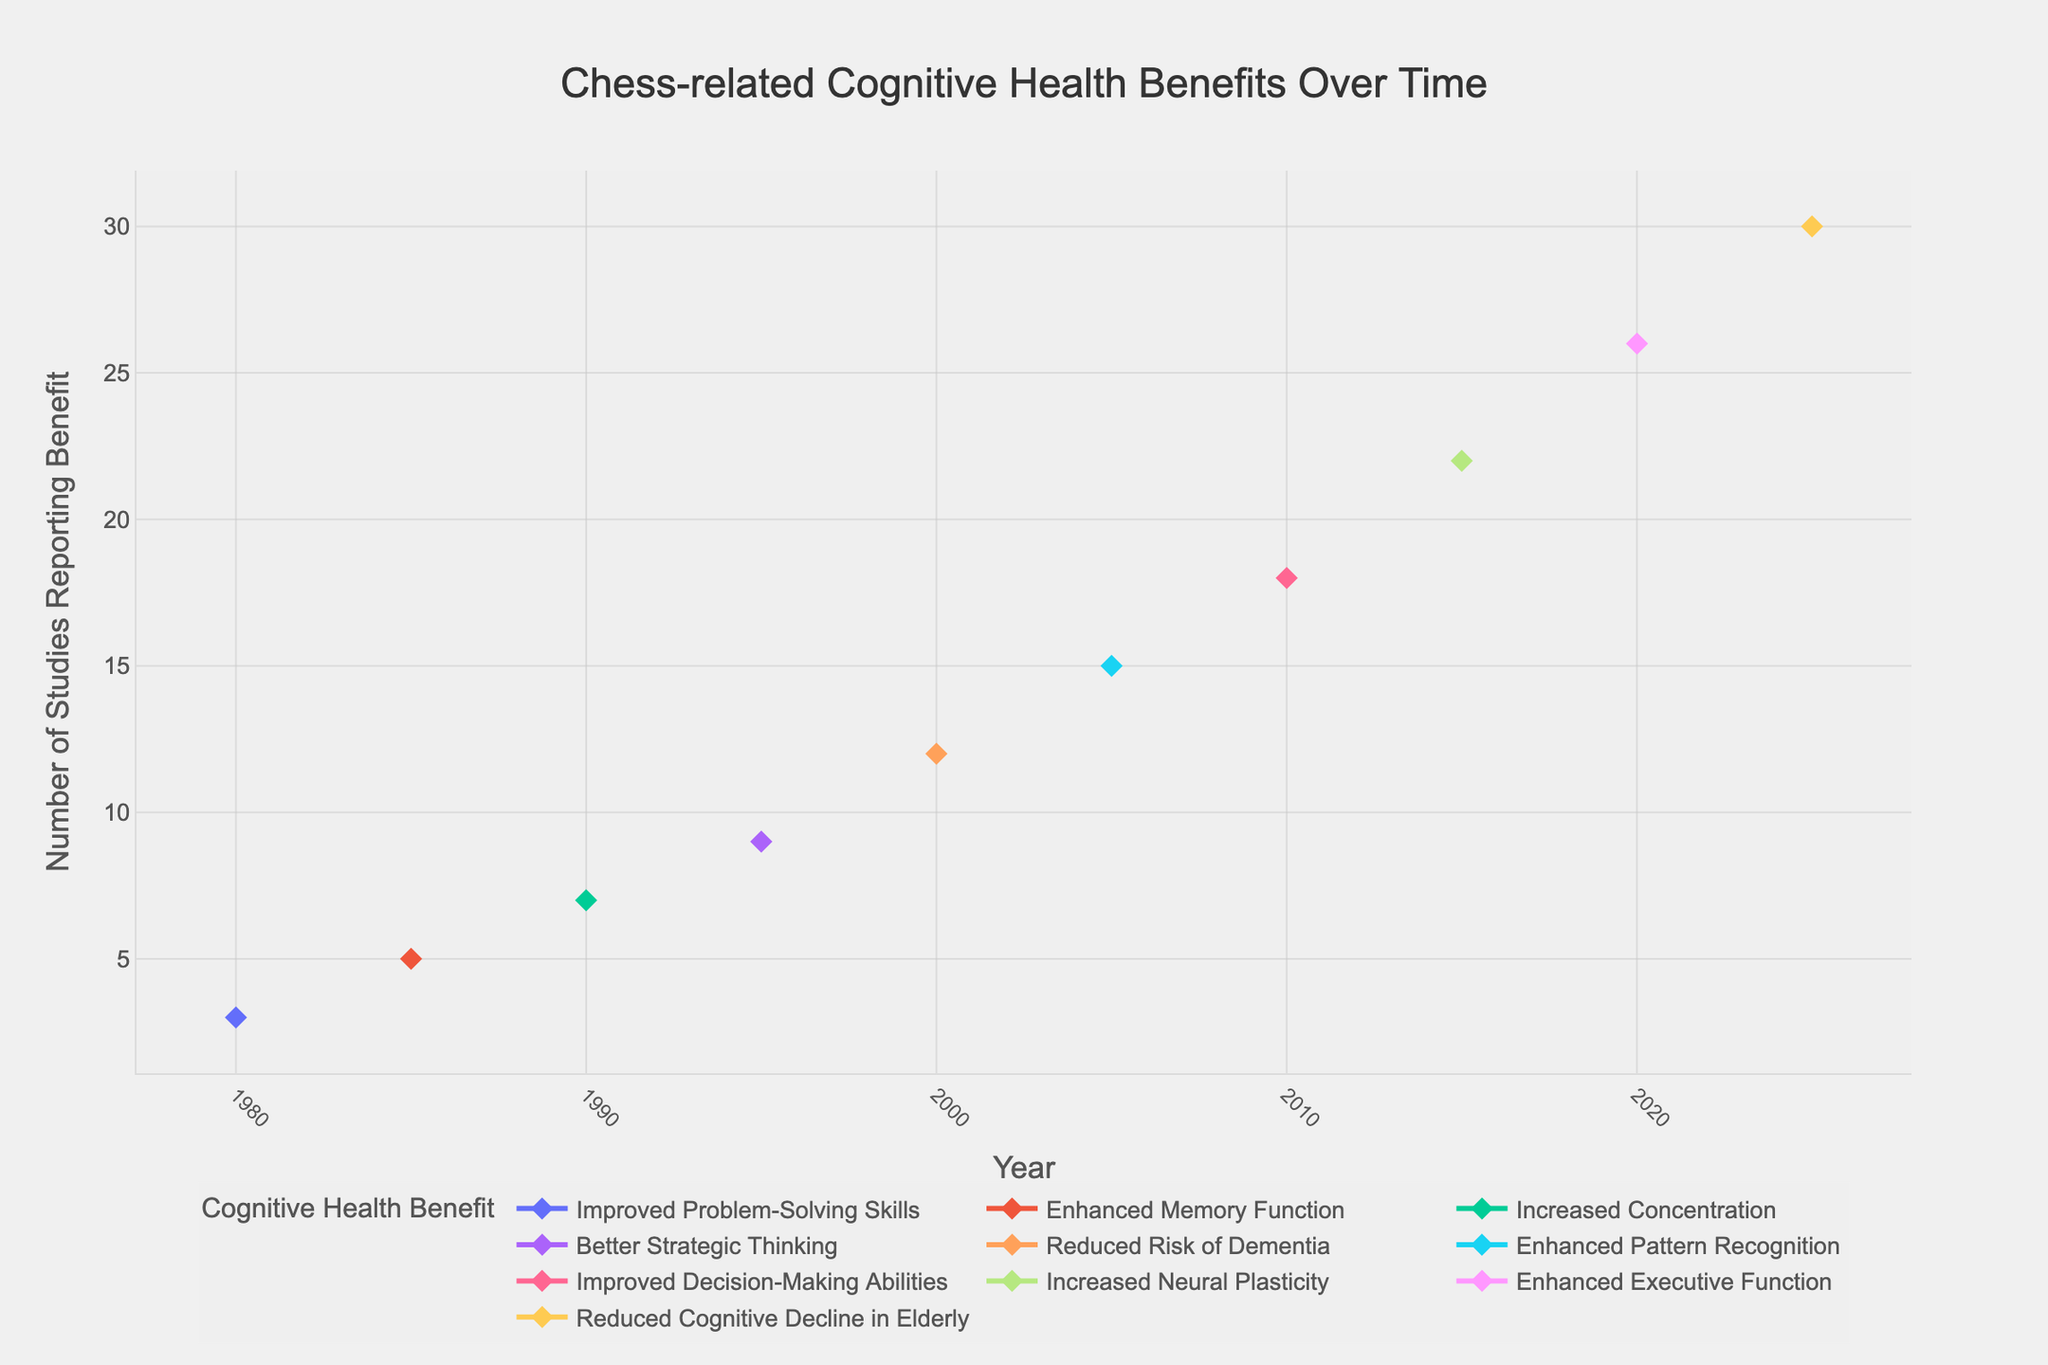What's the total number of studies reporting benefits in 2025? To find the total number of studies reporting benefits in 2025, look at the data point for that year. In 2025, the benefit reported is "Reduced Cognitive Decline in Elderly" with 30 studies.
Answer: 30 Which cognitive health benefit had the highest number of studies reported in 2010? Look at the data points for 2010 and identify the cognitive health benefit with the highest number of studies. In 2010, "Improved Decision-Making Abilities" has the highest with 18 studies.
Answer: Improved Decision-Making Abilities How did the number of studies on "Reduced Risk of Dementia" change from 2000 to 2005? Look at the data points for "Reduced Risk of Dementia" in 2000 and 2005. In 2000, there are 12 studies, and by 2005, this number has changed to 15 studies. The change is 15 - 12 = 3 studies.
Answer: Increased by 3 What is the average number of studies reporting benefits in the years 1980, 1990, and 2000? Calculate the average by adding the number of studies reporting benefits in 1980 (3), 1990 (7), and 2000 (12) and then dividing by the number of years. (3 + 7 + 12) / 3 equals 22 / 3 which is approximately 7.33.
Answer: 7.33 What pattern can be observed in the number of studies reporting cognitive health benefits over time? Observe the trend line created by the data points over the years. From 1980 to 2025, the number of studies generally increases, showing a growing interest and recognition of cognitive health benefits related to chess.
Answer: Increasing trend Which cognitive health benefit had exactly 9 studies reported in 1995? Look at the data points for 1995 to identify the cognitive health benefit with exactly 9 studies. The benefit "Better Strategic Thinking" had 9 studies reported that year.
Answer: Better Strategic Thinking Between 2005 and 2020, which cognitive health benefit shows the most significant increase in studies? Compare the benefits reported in 2005 and 2020. In 2005, "Enhanced Pattern Recognition" had 15 studies, and in 2020, "Enhanced Executive Function" had 26 studies. The most significant increase is for "Enhanced Executive Function" with an increase of 26 - 15 = 11 studies.
Answer: Enhanced Executive Function What is the difference between the number of studies reporting "Enhanced Memory Function" in 1985 and "Increased Neural Plasticity" in 2015? Look at the data points for these benefits in the respective years: "Enhanced Memory Function" in 1985 had 5 studies, and "Increased Neural Plasticity" in 2015 had 22 studies. The difference is 22 - 5 = 17.
Answer: 17 Which year had the fewest studies reporting cognitive health benefits, and what was the benefit? Look at the data points across all years for the number of studies. In 1980, the fewest studies were reported, with "Improved Problem-Solving Skills" having 3 studies.
Answer: 1980, Improved Problem-Solving Skills 